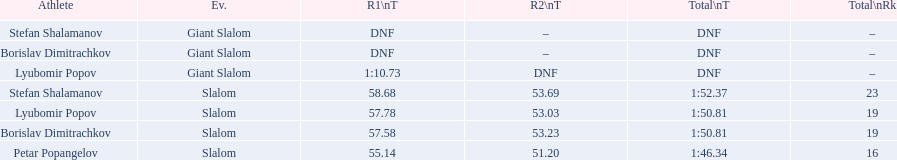Which athletes had consecutive times under 58 for both races? Lyubomir Popov, Borislav Dimitrachkov, Petar Popangelov. 